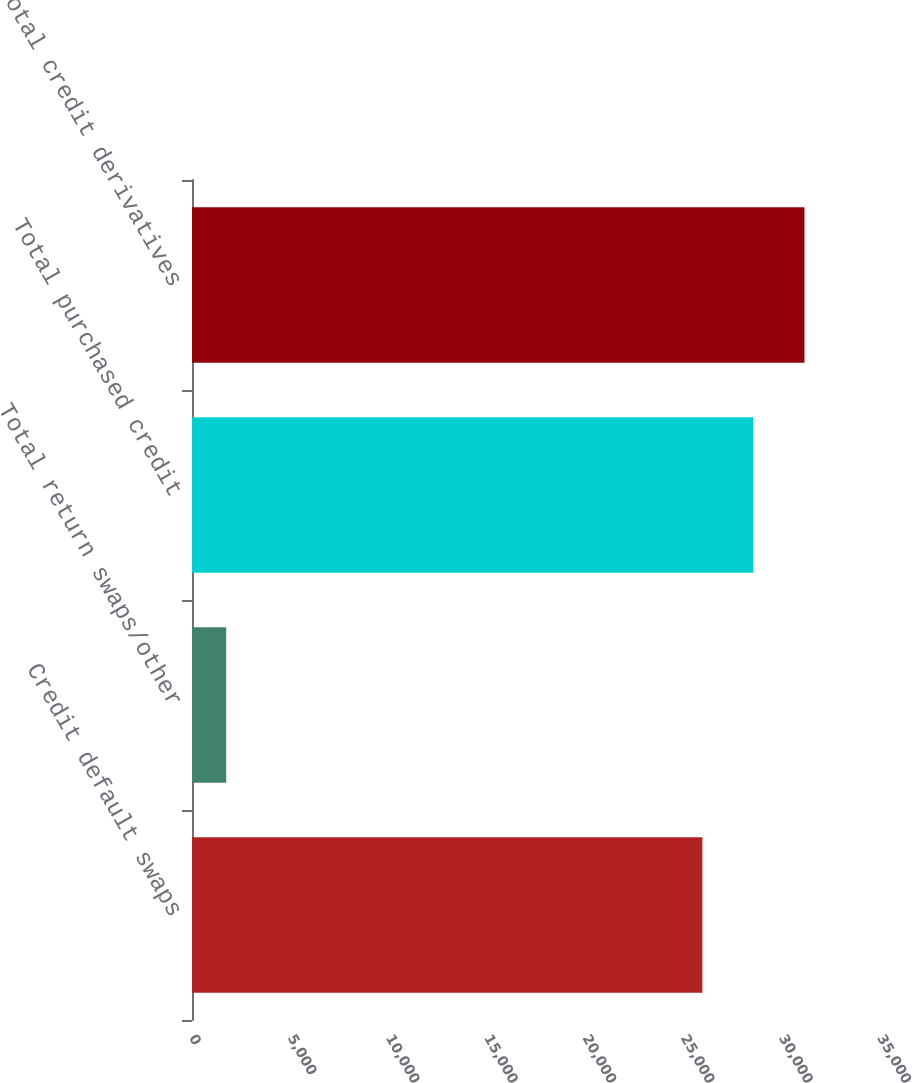Convert chart to OTSL. <chart><loc_0><loc_0><loc_500><loc_500><bar_chart><fcel>Credit default swaps<fcel>Total return swaps/other<fcel>Total purchased credit<fcel>Total credit derivatives<nl><fcel>25964<fcel>1740<fcel>28560.4<fcel>31156.8<nl></chart> 